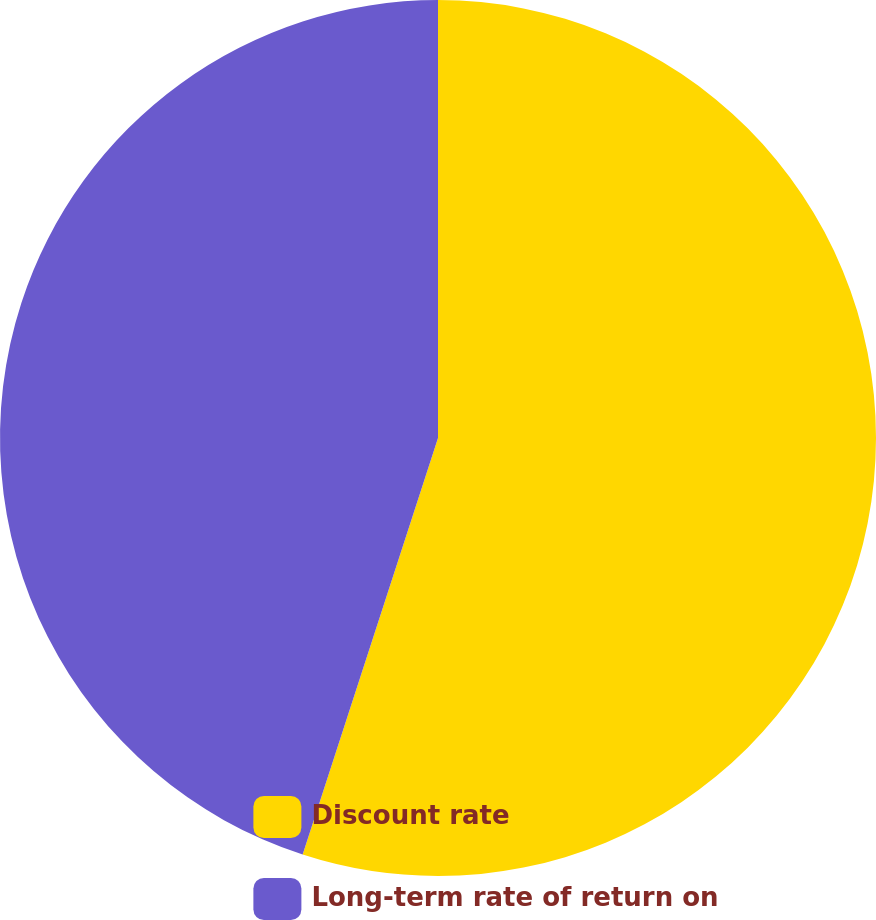Convert chart. <chart><loc_0><loc_0><loc_500><loc_500><pie_chart><fcel>Discount rate<fcel>Long-term rate of return on<nl><fcel>55.0%<fcel>45.0%<nl></chart> 